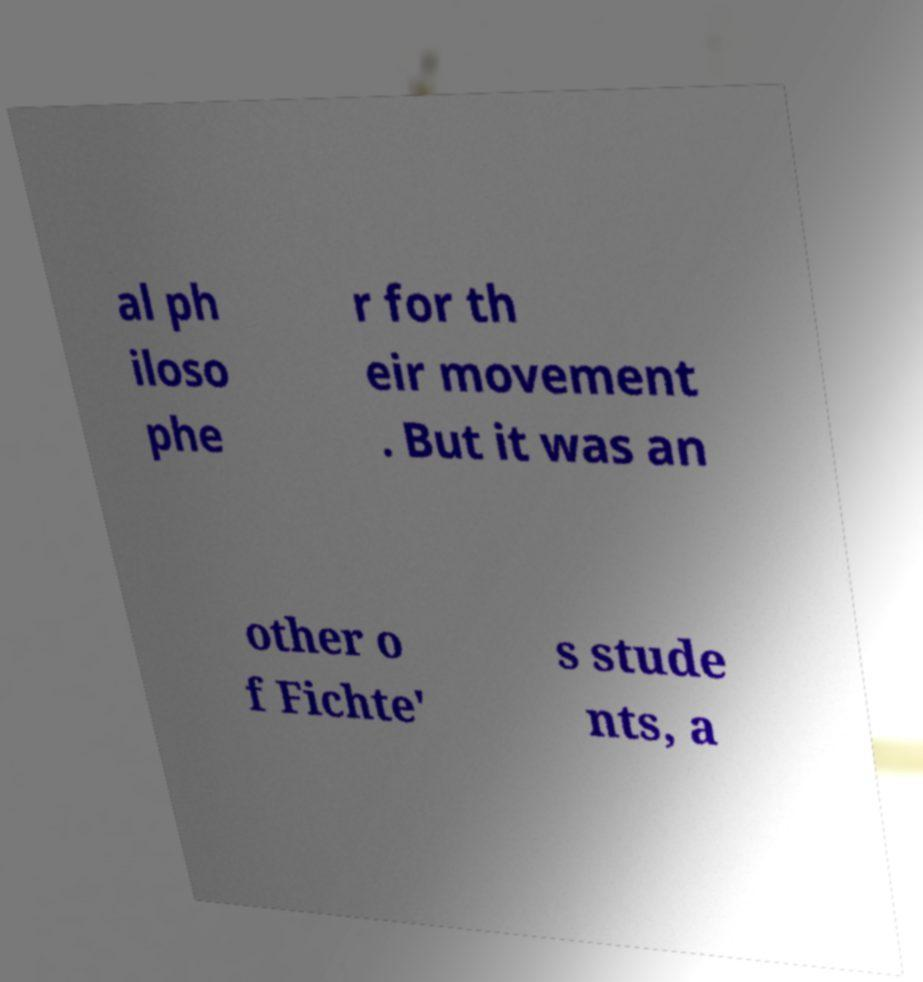Please read and relay the text visible in this image. What does it say? al ph iloso phe r for th eir movement . But it was an other o f Fichte' s stude nts, a 